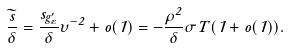<formula> <loc_0><loc_0><loc_500><loc_500>\frac { \widetilde { s } } { \delta } = \frac { s _ { g _ { \varepsilon } ^ { \prime } } } { \delta } \upsilon ^ { - 2 } + o ( 1 ) = - \frac { \rho ^ { 2 } } { \delta } \sigma T ( 1 + o ( 1 ) ) .</formula> 